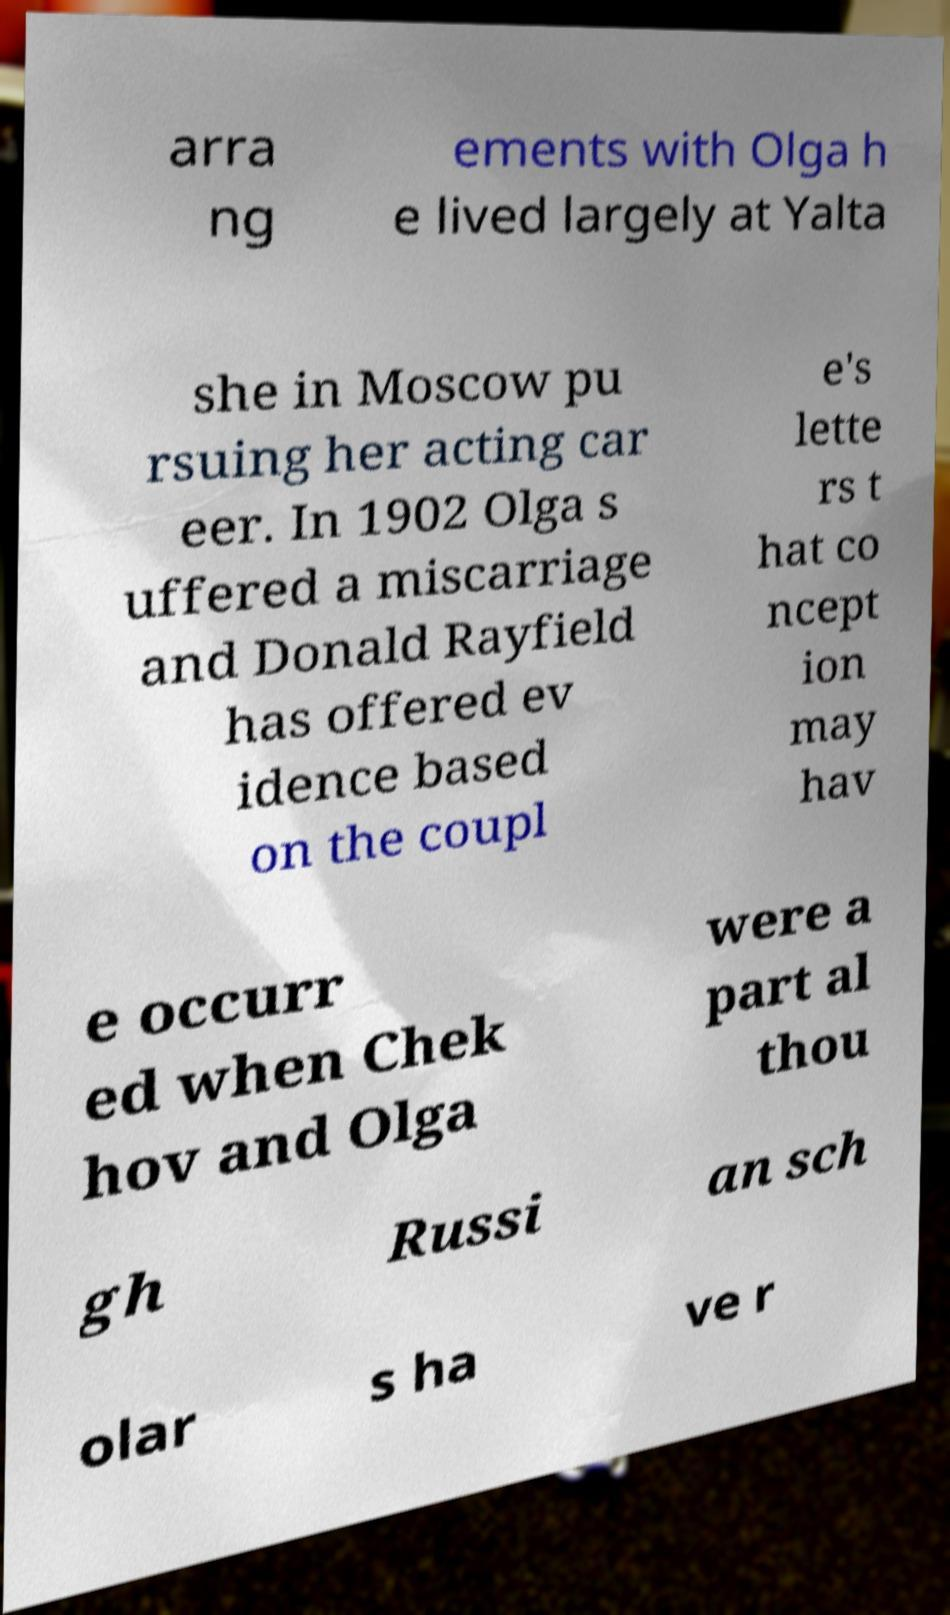What messages or text are displayed in this image? I need them in a readable, typed format. arra ng ements with Olga h e lived largely at Yalta she in Moscow pu rsuing her acting car eer. In 1902 Olga s uffered a miscarriage and Donald Rayfield has offered ev idence based on the coupl e's lette rs t hat co ncept ion may hav e occurr ed when Chek hov and Olga were a part al thou gh Russi an sch olar s ha ve r 